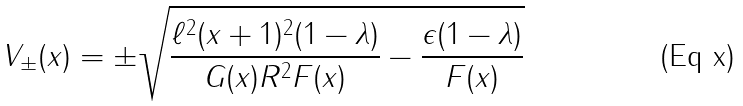<formula> <loc_0><loc_0><loc_500><loc_500>V _ { \pm } ( x ) = \pm \sqrt { \frac { \ell ^ { 2 } ( x + 1 ) ^ { 2 } ( 1 - \lambda ) } { G ( x ) R ^ { 2 } F ( x ) } - \frac { \epsilon ( 1 - \lambda ) } { F ( x ) } }</formula> 